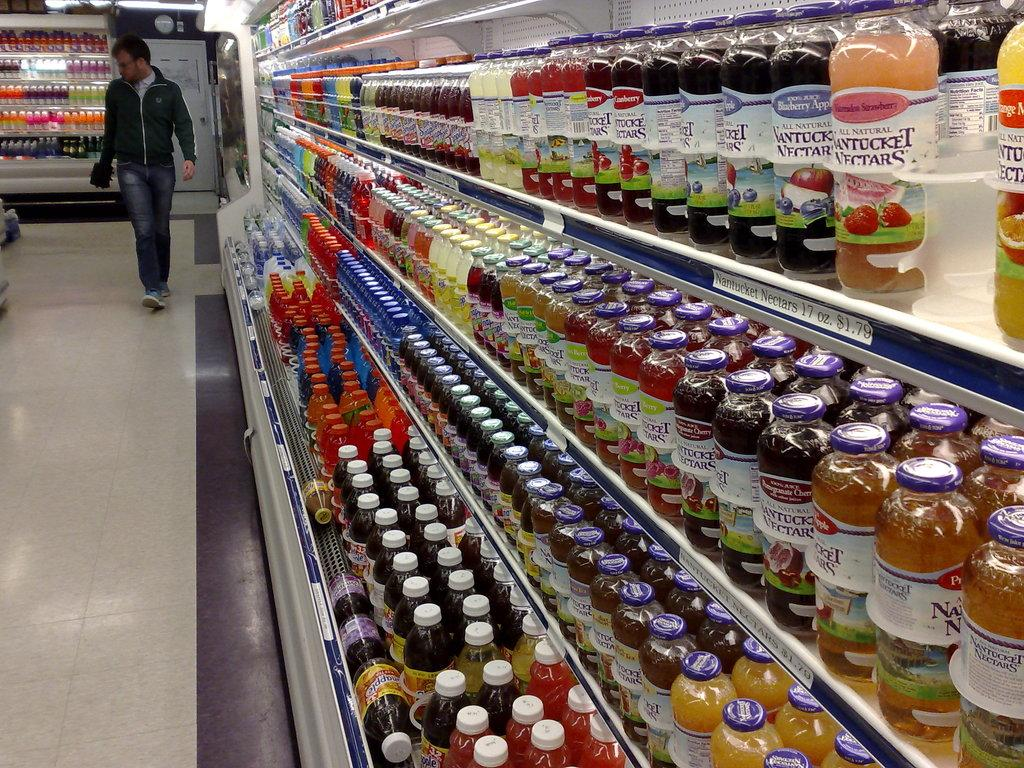Who is present in the image? There is a man in the image. What is the man doing in the image? The man is walking on the floor. What can be seen on the right side of the image? There are preservative drinking bottles in the racks on the right side of the image. What caused the power outage in the image? There is no mention of a power outage in the image, so it cannot be determined from the image. 